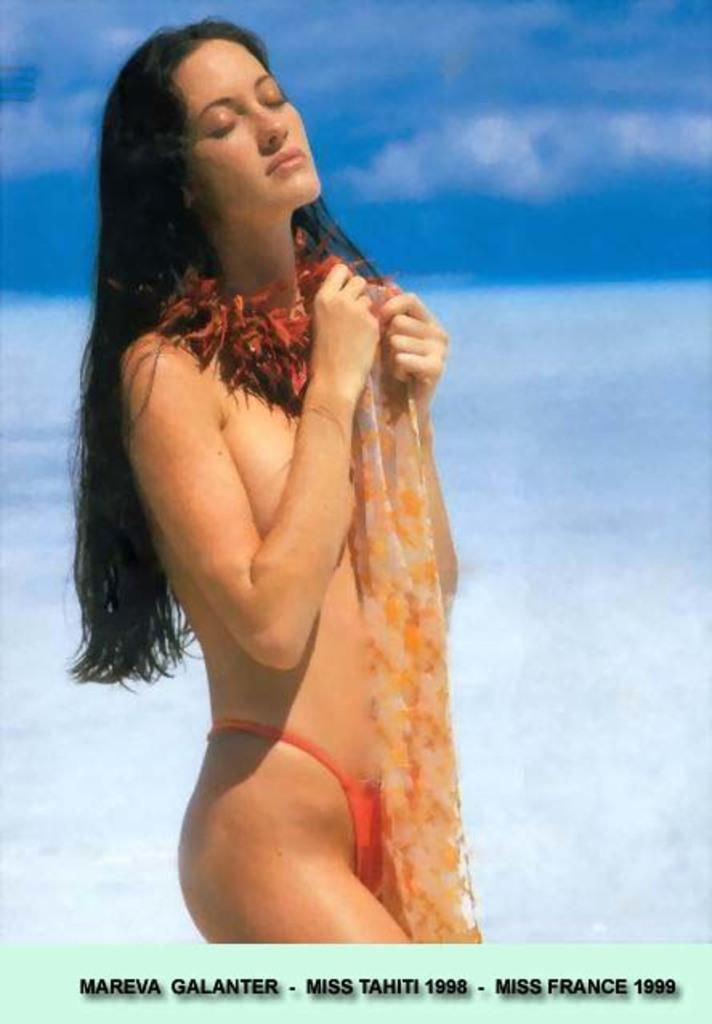Who is the main subject in the image? There is a woman in the image. What is the woman doing in the image? The woman is standing in the image. What is the woman holding in the image? The woman is holding cloth in the image. What colors are present in the background of the image? The background of the image is white and blue. What type of attraction can be seen in the background of the image? There is no attraction present in the image; the background is white and blue. What riddle is the woman trying to solve in the image? There is no riddle present in the image; the woman is simply standing and holding cloth. 